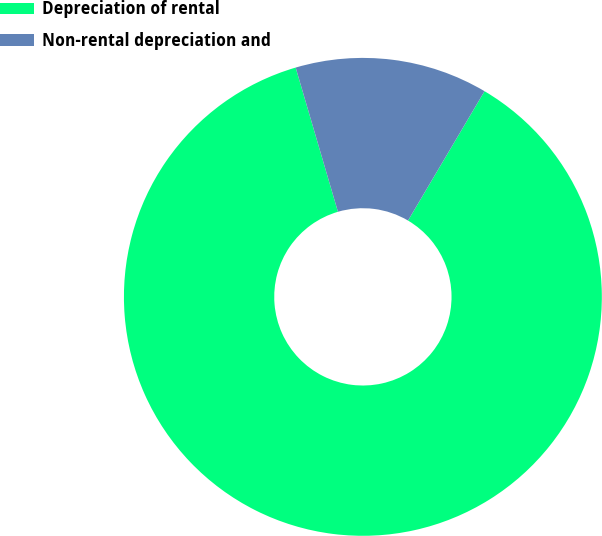Convert chart to OTSL. <chart><loc_0><loc_0><loc_500><loc_500><pie_chart><fcel>Depreciation of rental<fcel>Non-rental depreciation and<nl><fcel>86.96%<fcel>13.04%<nl></chart> 